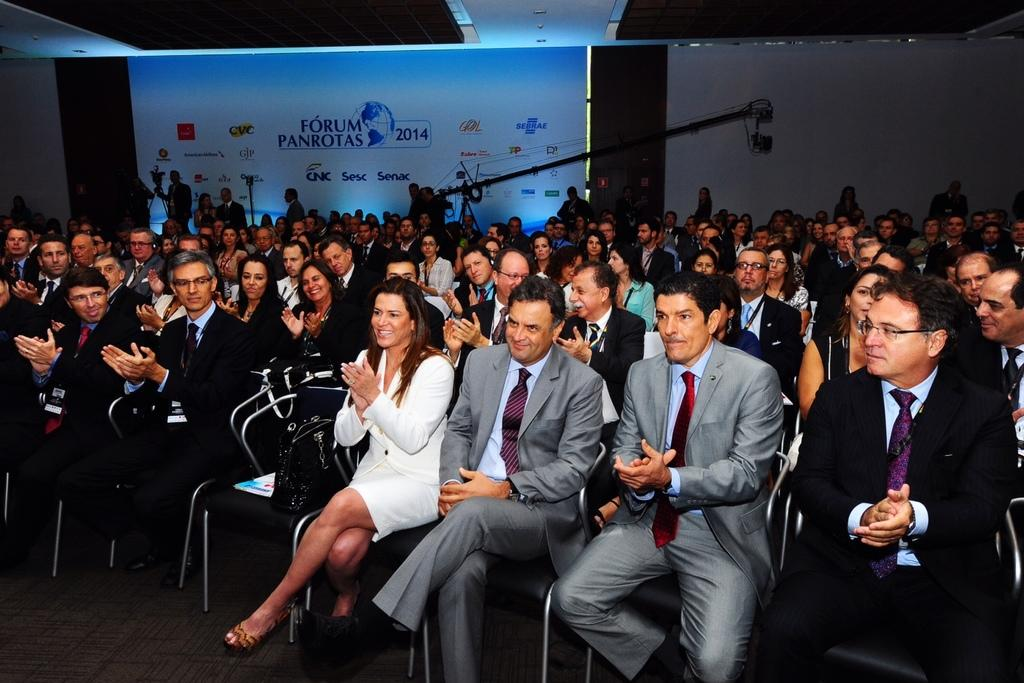What are the people in the image doing? The people in the image are sitting on chairs. What is on the chair besides the people? There is a bag and a book on the chair. Can you describe the background of the image? There are people and a poster in the background of the image. What type of competition is being held in the image? There is no competition present in the image. What leaf is being used to illustrate the theory in the image? There is no leaf or theory present in the image. 